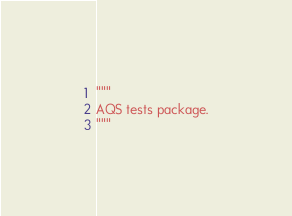<code> <loc_0><loc_0><loc_500><loc_500><_Python_>"""
AQS tests package.
"""
</code> 